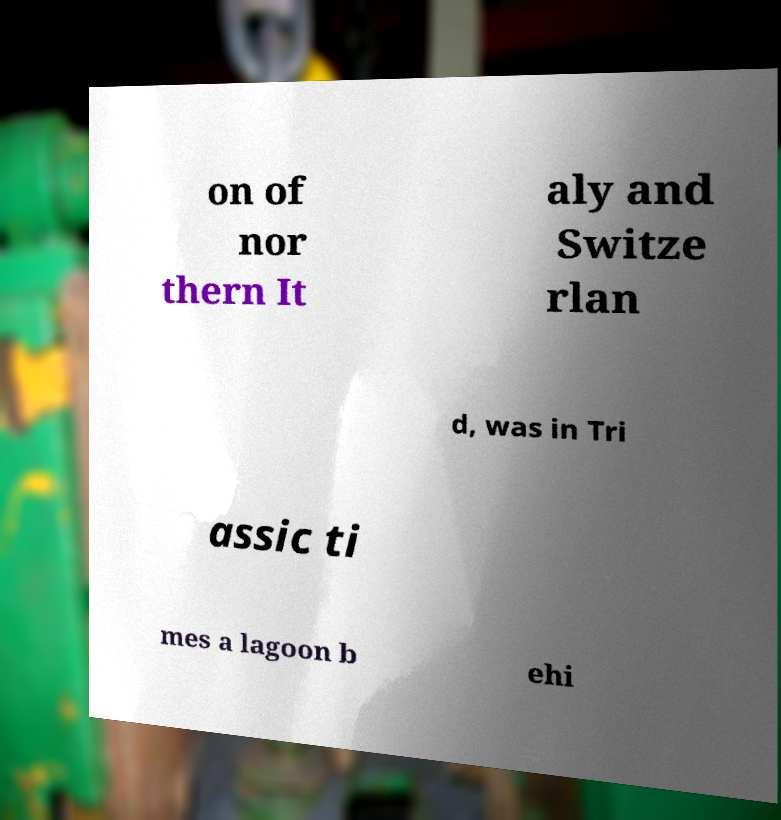I need the written content from this picture converted into text. Can you do that? on of nor thern It aly and Switze rlan d, was in Tri assic ti mes a lagoon b ehi 